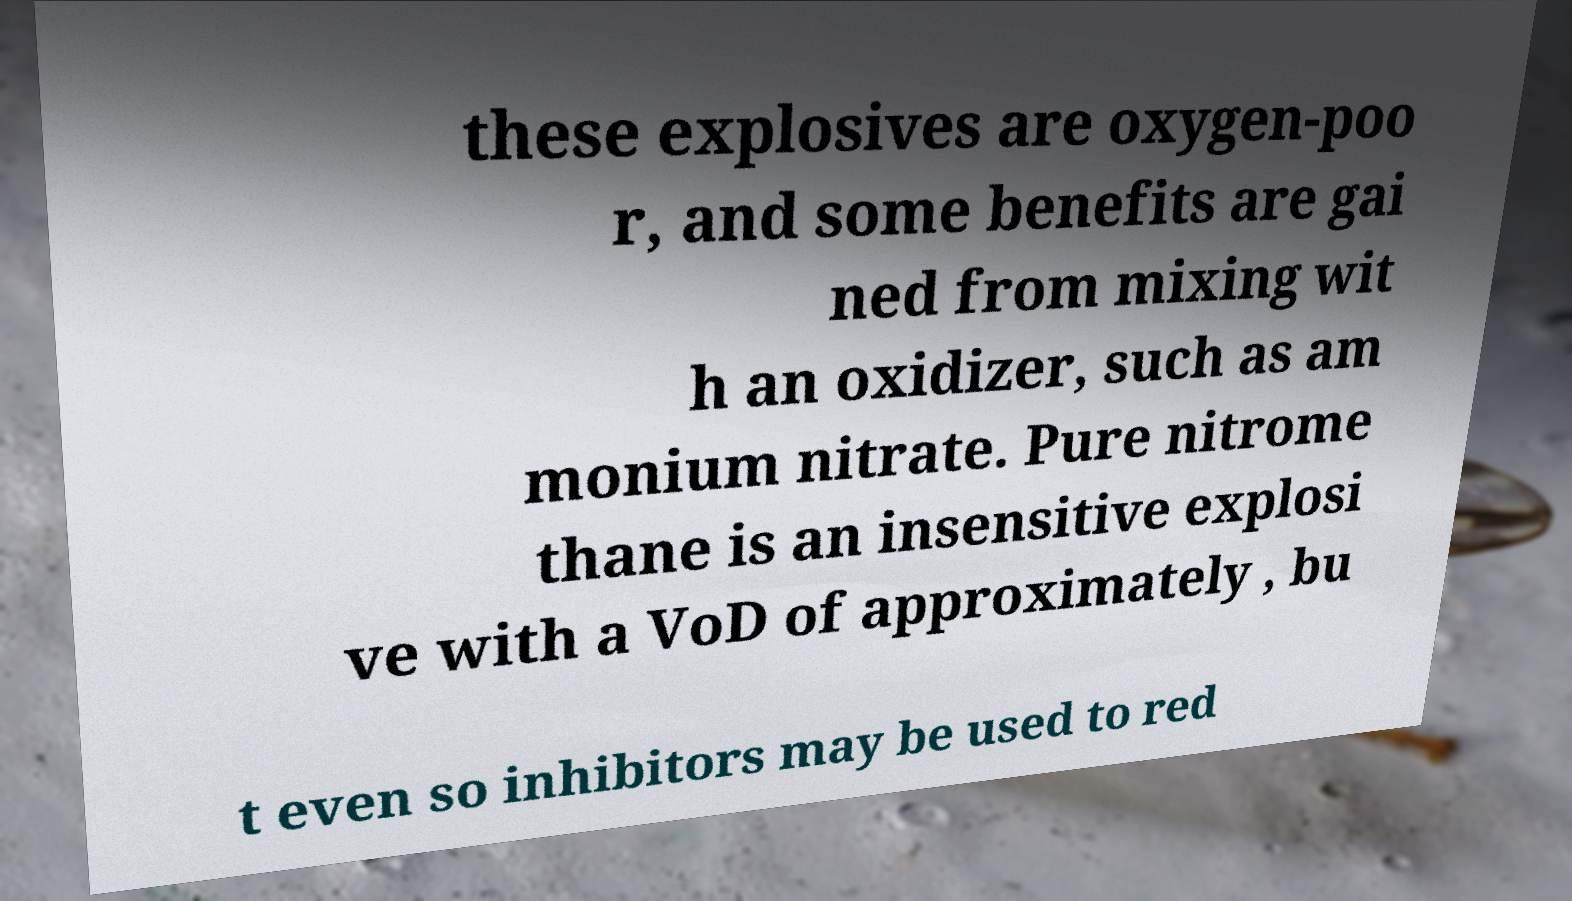Can you read and provide the text displayed in the image?This photo seems to have some interesting text. Can you extract and type it out for me? these explosives are oxygen-poo r, and some benefits are gai ned from mixing wit h an oxidizer, such as am monium nitrate. Pure nitrome thane is an insensitive explosi ve with a VoD of approximately , bu t even so inhibitors may be used to red 